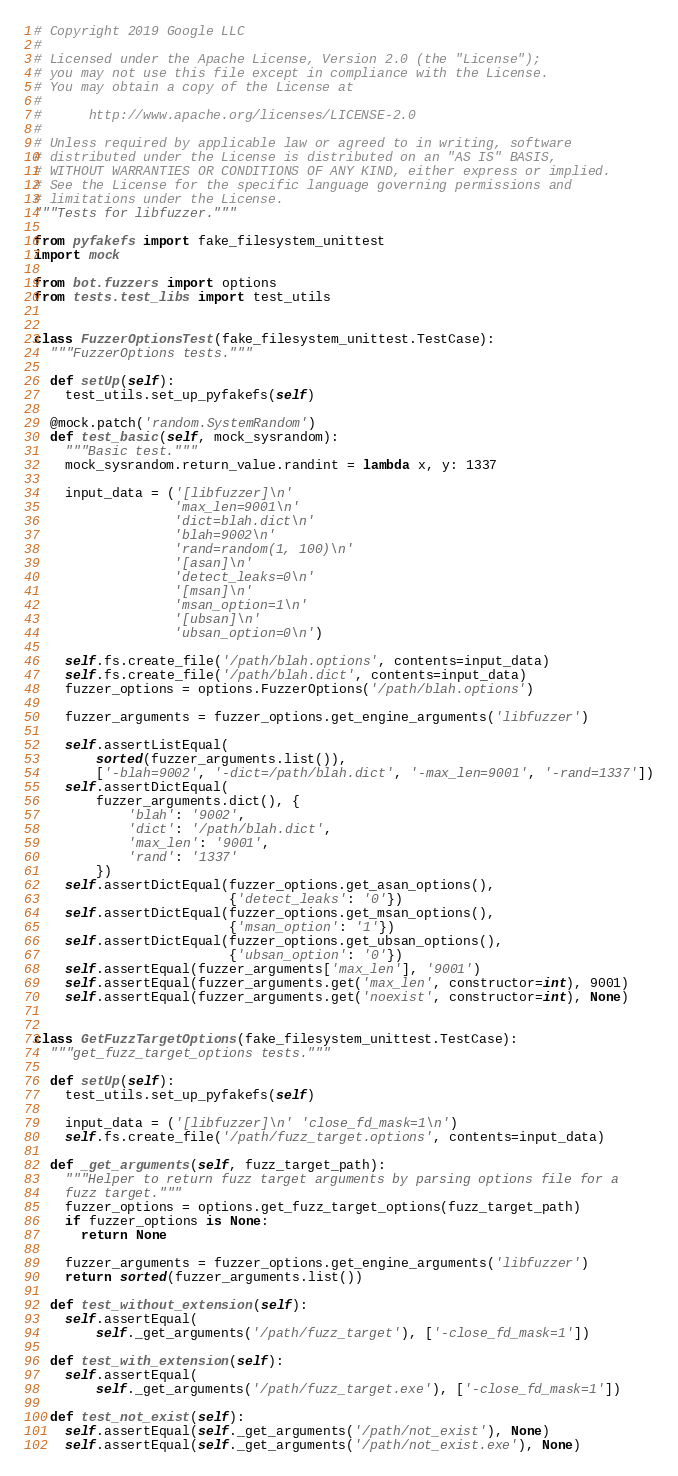Convert code to text. <code><loc_0><loc_0><loc_500><loc_500><_Python_># Copyright 2019 Google LLC
#
# Licensed under the Apache License, Version 2.0 (the "License");
# you may not use this file except in compliance with the License.
# You may obtain a copy of the License at
#
#      http://www.apache.org/licenses/LICENSE-2.0
#
# Unless required by applicable law or agreed to in writing, software
# distributed under the License is distributed on an "AS IS" BASIS,
# WITHOUT WARRANTIES OR CONDITIONS OF ANY KIND, either express or implied.
# See the License for the specific language governing permissions and
# limitations under the License.
"""Tests for libfuzzer."""

from pyfakefs import fake_filesystem_unittest
import mock

from bot.fuzzers import options
from tests.test_libs import test_utils


class FuzzerOptionsTest(fake_filesystem_unittest.TestCase):
  """FuzzerOptions tests."""

  def setUp(self):
    test_utils.set_up_pyfakefs(self)

  @mock.patch('random.SystemRandom')
  def test_basic(self, mock_sysrandom):
    """Basic test."""
    mock_sysrandom.return_value.randint = lambda x, y: 1337

    input_data = ('[libfuzzer]\n'
                  'max_len=9001\n'
                  'dict=blah.dict\n'
                  'blah=9002\n'
                  'rand=random(1, 100)\n'
                  '[asan]\n'
                  'detect_leaks=0\n'
                  '[msan]\n'
                  'msan_option=1\n'
                  '[ubsan]\n'
                  'ubsan_option=0\n')

    self.fs.create_file('/path/blah.options', contents=input_data)
    self.fs.create_file('/path/blah.dict', contents=input_data)
    fuzzer_options = options.FuzzerOptions('/path/blah.options')

    fuzzer_arguments = fuzzer_options.get_engine_arguments('libfuzzer')

    self.assertListEqual(
        sorted(fuzzer_arguments.list()),
        ['-blah=9002', '-dict=/path/blah.dict', '-max_len=9001', '-rand=1337'])
    self.assertDictEqual(
        fuzzer_arguments.dict(), {
            'blah': '9002',
            'dict': '/path/blah.dict',
            'max_len': '9001',
            'rand': '1337'
        })
    self.assertDictEqual(fuzzer_options.get_asan_options(),
                         {'detect_leaks': '0'})
    self.assertDictEqual(fuzzer_options.get_msan_options(),
                         {'msan_option': '1'})
    self.assertDictEqual(fuzzer_options.get_ubsan_options(),
                         {'ubsan_option': '0'})
    self.assertEqual(fuzzer_arguments['max_len'], '9001')
    self.assertEqual(fuzzer_arguments.get('max_len', constructor=int), 9001)
    self.assertEqual(fuzzer_arguments.get('noexist', constructor=int), None)


class GetFuzzTargetOptions(fake_filesystem_unittest.TestCase):
  """get_fuzz_target_options tests."""

  def setUp(self):
    test_utils.set_up_pyfakefs(self)

    input_data = ('[libfuzzer]\n' 'close_fd_mask=1\n')
    self.fs.create_file('/path/fuzz_target.options', contents=input_data)

  def _get_arguments(self, fuzz_target_path):
    """Helper to return fuzz target arguments by parsing options file for a
    fuzz target."""
    fuzzer_options = options.get_fuzz_target_options(fuzz_target_path)
    if fuzzer_options is None:
      return None

    fuzzer_arguments = fuzzer_options.get_engine_arguments('libfuzzer')
    return sorted(fuzzer_arguments.list())

  def test_without_extension(self):
    self.assertEqual(
        self._get_arguments('/path/fuzz_target'), ['-close_fd_mask=1'])

  def test_with_extension(self):
    self.assertEqual(
        self._get_arguments('/path/fuzz_target.exe'), ['-close_fd_mask=1'])

  def test_not_exist(self):
    self.assertEqual(self._get_arguments('/path/not_exist'), None)
    self.assertEqual(self._get_arguments('/path/not_exist.exe'), None)
</code> 